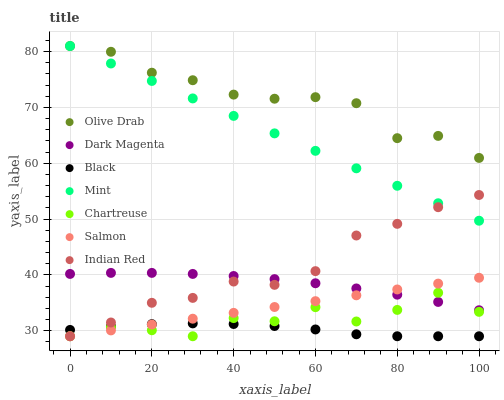Does Black have the minimum area under the curve?
Answer yes or no. Yes. Does Olive Drab have the maximum area under the curve?
Answer yes or no. Yes. Does Salmon have the minimum area under the curve?
Answer yes or no. No. Does Salmon have the maximum area under the curve?
Answer yes or no. No. Is Mint the smoothest?
Answer yes or no. Yes. Is Chartreuse the roughest?
Answer yes or no. Yes. Is Salmon the smoothest?
Answer yes or no. No. Is Salmon the roughest?
Answer yes or no. No. Does Salmon have the lowest value?
Answer yes or no. Yes. Does Mint have the lowest value?
Answer yes or no. No. Does Olive Drab have the highest value?
Answer yes or no. Yes. Does Salmon have the highest value?
Answer yes or no. No. Is Dark Magenta less than Olive Drab?
Answer yes or no. Yes. Is Mint greater than Salmon?
Answer yes or no. Yes. Does Dark Magenta intersect Indian Red?
Answer yes or no. Yes. Is Dark Magenta less than Indian Red?
Answer yes or no. No. Is Dark Magenta greater than Indian Red?
Answer yes or no. No. Does Dark Magenta intersect Olive Drab?
Answer yes or no. No. 